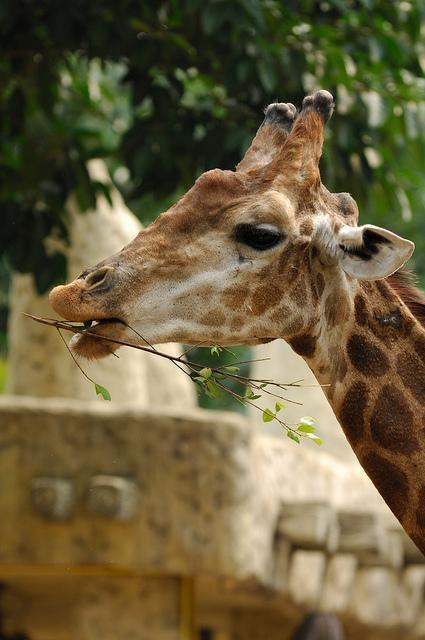How many giraffes are there?
Give a very brief answer. 1. 